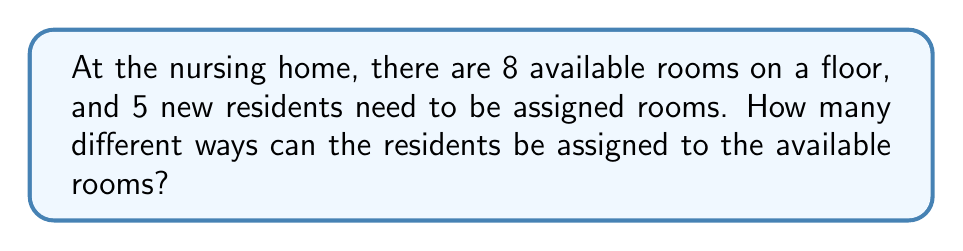Could you help me with this problem? Let's approach this step-by-step:

1) This is a permutation problem. We are selecting 5 rooms out of 8 and arranging the residents in these rooms.

2) The order matters because each resident is assigned to a specific room.

3) We can use the permutation formula:
   $$P(n,r) = \frac{n!}{(n-r)!}$$
   where $n$ is the total number of items to choose from, and $r$ is the number of items being chosen.

4) In this case, $n = 8$ (total rooms) and $r = 5$ (residents to be assigned).

5) Plugging these values into the formula:
   $$P(8,5) = \frac{8!}{(8-5)!} = \frac{8!}{3!}$$

6) Expanding this:
   $$\frac{8 * 7 * 6 * 5 * 4 * 3!}{3!}$$

7) The $3!$ cancels out in the numerator and denominator:
   $$8 * 7 * 6 * 5 * 4 = 6720$$

Therefore, there are 6720 different ways to assign the 5 residents to the 8 available rooms.
Answer: 6720 